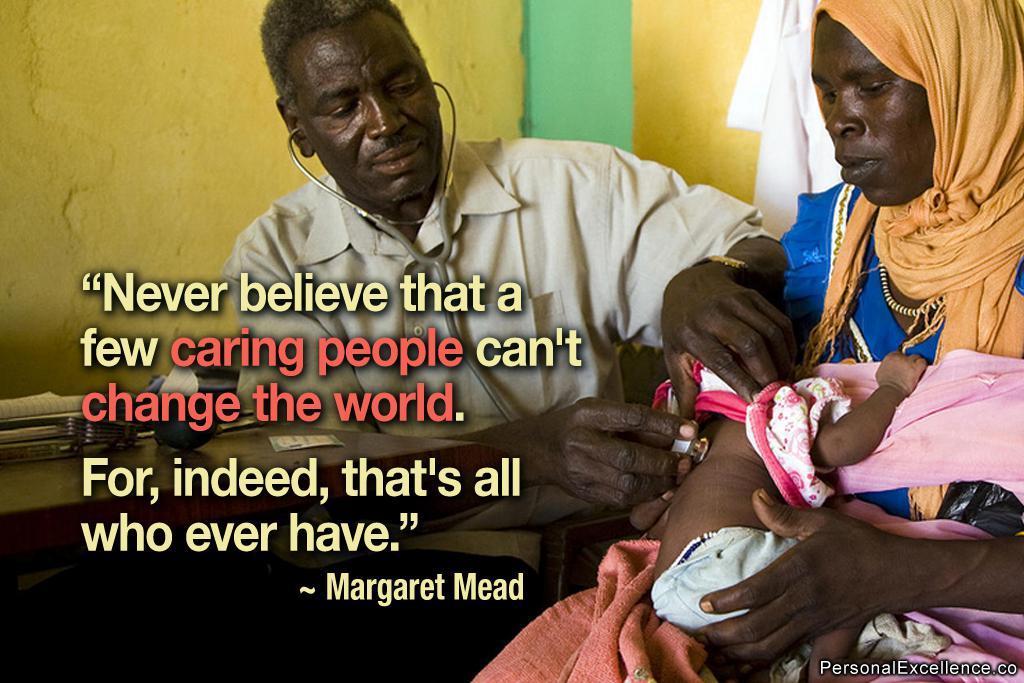In one or two sentences, can you explain what this image depicts? This is an advertisement. In the center of the image a man is sitting and holding stethoscope. On the right side of the image a lady is sitting and holding a baby. On the left side of the image there is a table. On the table we can see some objects, paper. In the background of the image we can see wall, cloth. In the middle of the image we can see some text. At the bottom right corner we can see some text. 